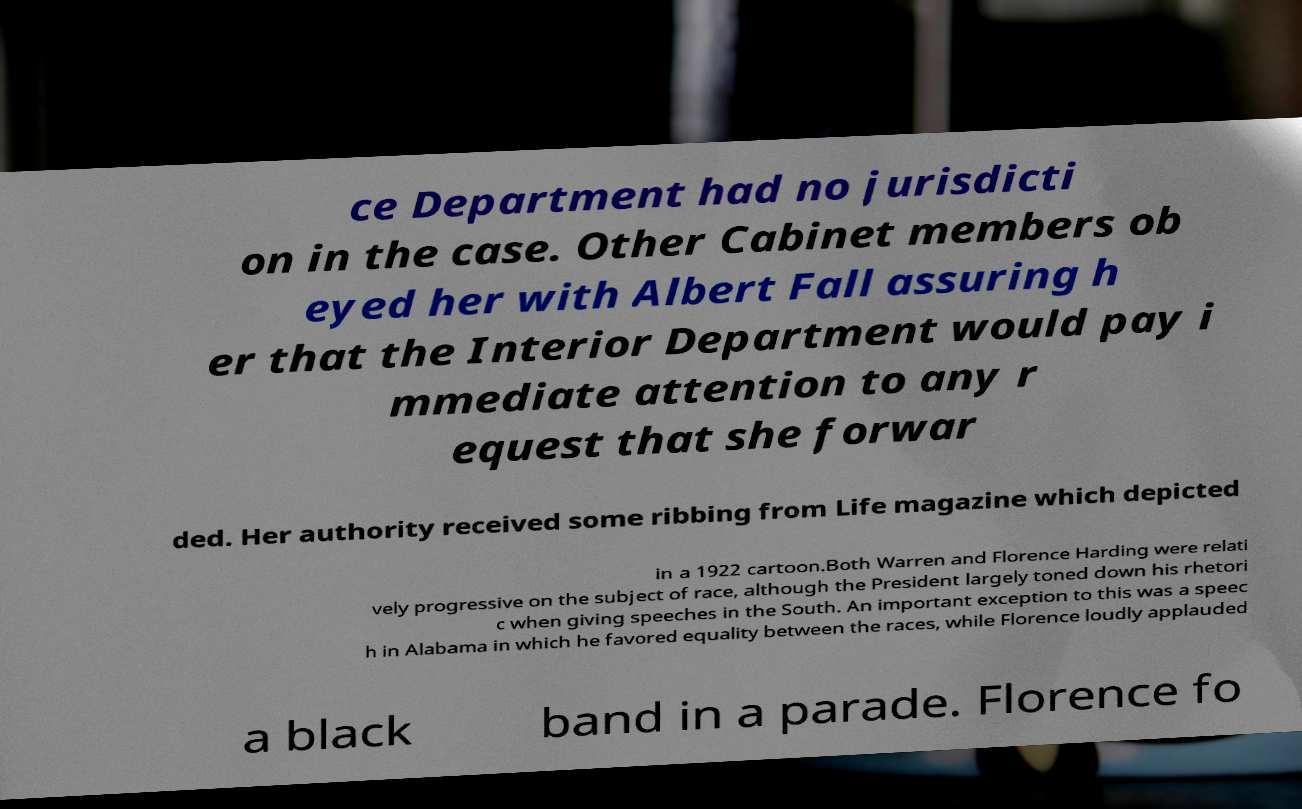Can you read and provide the text displayed in the image?This photo seems to have some interesting text. Can you extract and type it out for me? ce Department had no jurisdicti on in the case. Other Cabinet members ob eyed her with Albert Fall assuring h er that the Interior Department would pay i mmediate attention to any r equest that she forwar ded. Her authority received some ribbing from Life magazine which depicted in a 1922 cartoon.Both Warren and Florence Harding were relati vely progressive on the subject of race, although the President largely toned down his rhetori c when giving speeches in the South. An important exception to this was a speec h in Alabama in which he favored equality between the races, while Florence loudly applauded a black band in a parade. Florence fo 